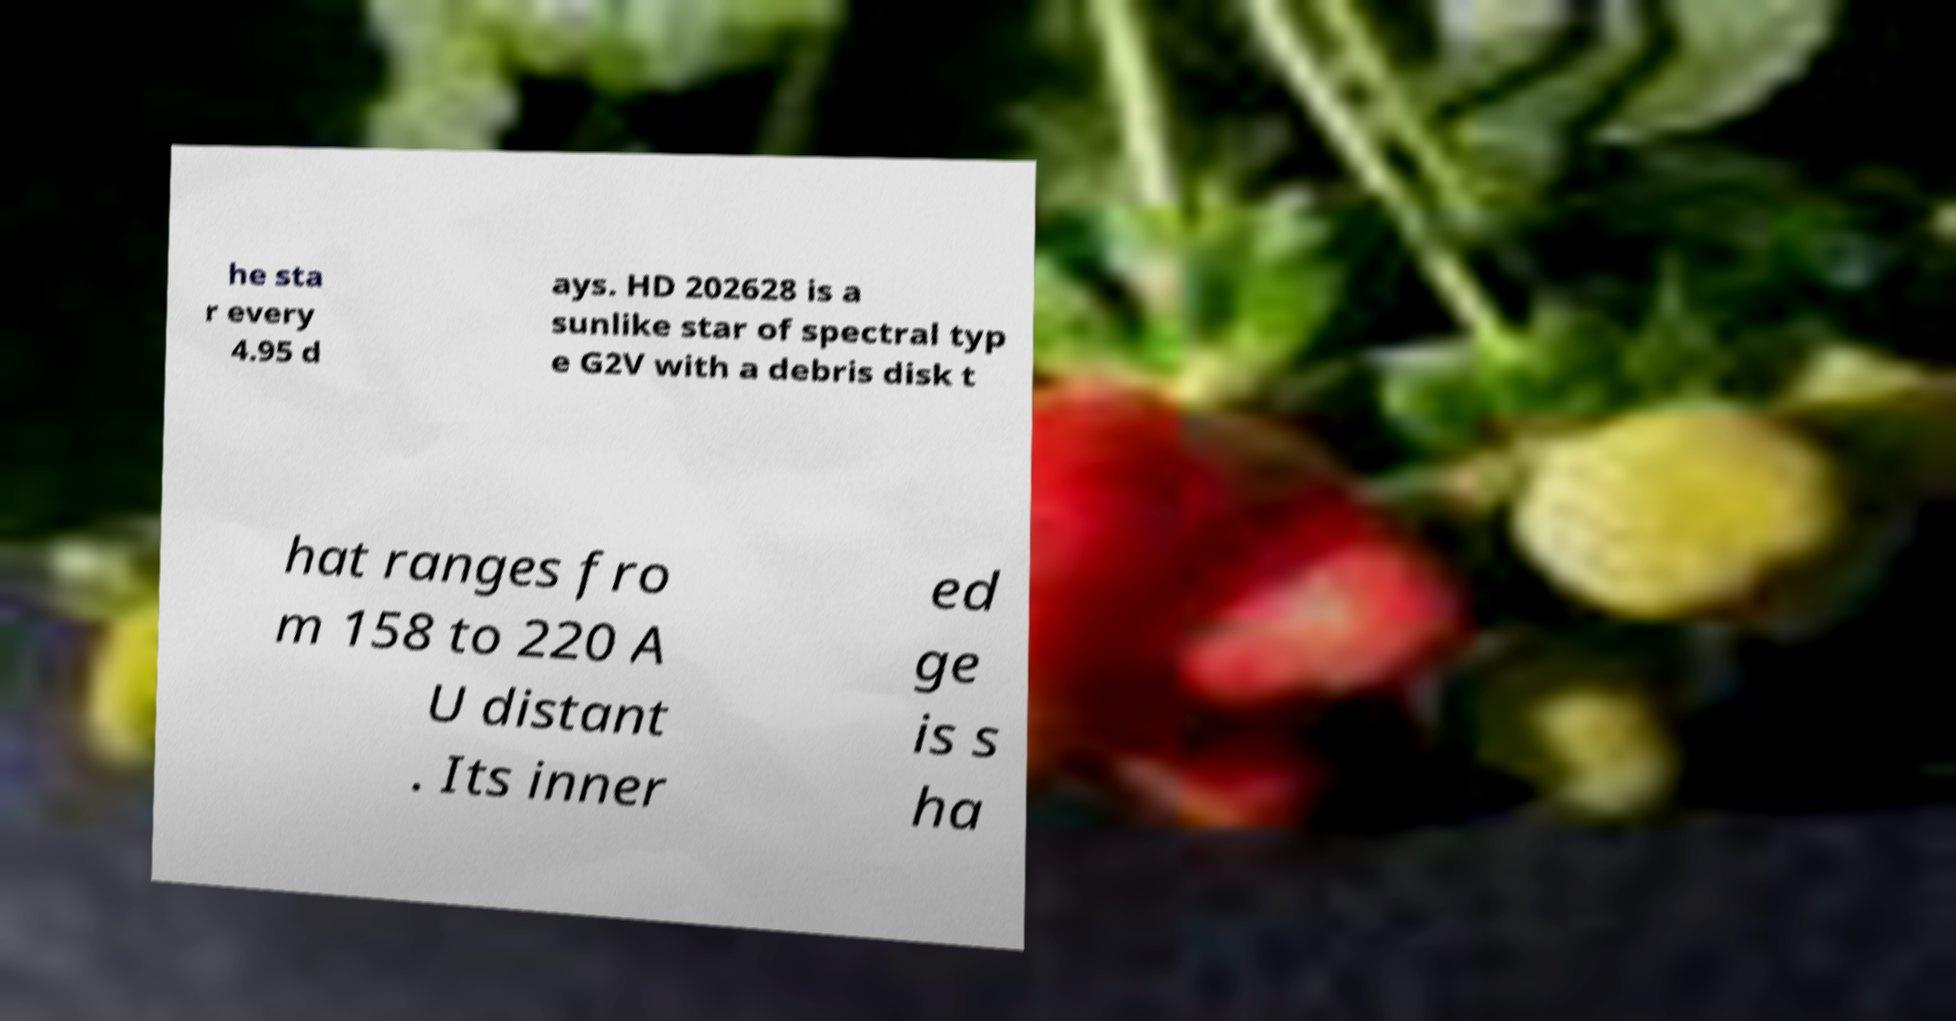Can you read and provide the text displayed in the image?This photo seems to have some interesting text. Can you extract and type it out for me? he sta r every 4.95 d ays. HD 202628 is a sunlike star of spectral typ e G2V with a debris disk t hat ranges fro m 158 to 220 A U distant . Its inner ed ge is s ha 